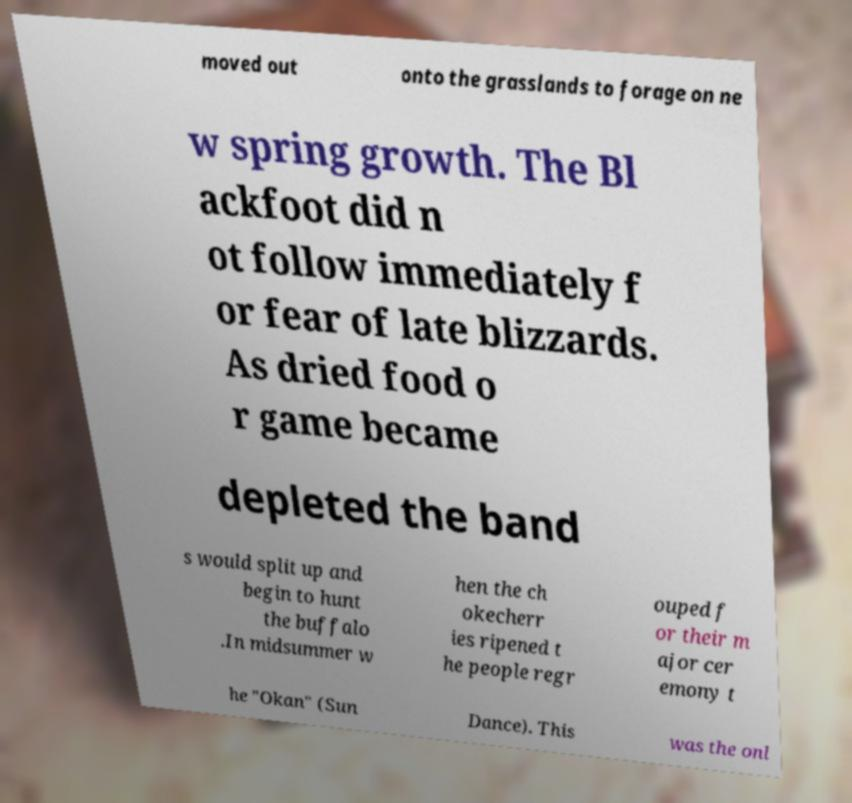Can you accurately transcribe the text from the provided image for me? moved out onto the grasslands to forage on ne w spring growth. The Bl ackfoot did n ot follow immediately f or fear of late blizzards. As dried food o r game became depleted the band s would split up and begin to hunt the buffalo .In midsummer w hen the ch okecherr ies ripened t he people regr ouped f or their m ajor cer emony t he "Okan" (Sun Dance). This was the onl 